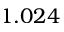Convert formula to latex. <formula><loc_0><loc_0><loc_500><loc_500>1 . 0 2 4</formula> 